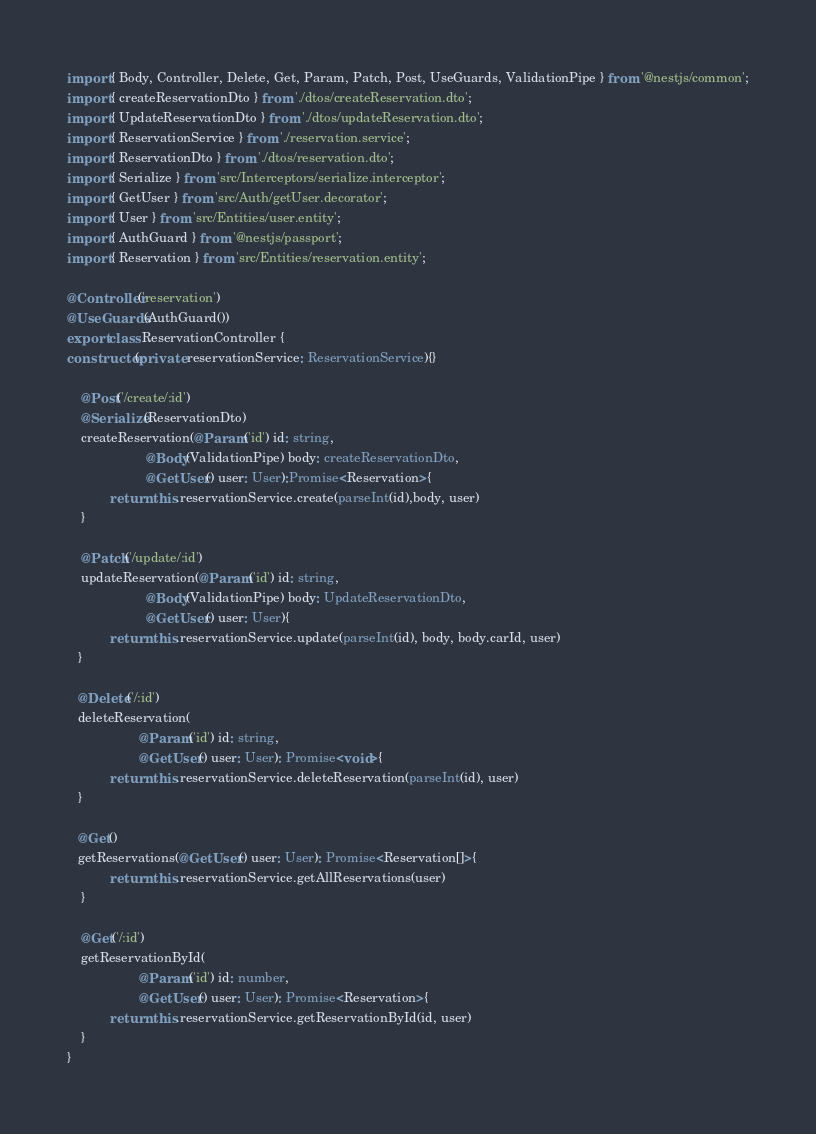Convert code to text. <code><loc_0><loc_0><loc_500><loc_500><_TypeScript_>import { Body, Controller, Delete, Get, Param, Patch, Post, UseGuards, ValidationPipe } from '@nestjs/common';
import { createReservationDto } from './dtos/createReservation.dto';
import { UpdateReservationDto } from './dtos/updateReservation.dto';
import { ReservationService } from './reservation.service';
import { ReservationDto } from './dtos/reservation.dto';
import { Serialize } from 'src/Interceptors/serialize.interceptor';
import { GetUser } from 'src/Auth/getUser.decorator';
import { User } from 'src/Entities/user.entity';
import { AuthGuard } from '@nestjs/passport';
import { Reservation } from 'src/Entities/reservation.entity';

@Controller('reservation')
@UseGuards(AuthGuard())
export class ReservationController {
constructor(private reservationService: ReservationService){}

    @Post('/create/:id')
    @Serialize(ReservationDto)
    createReservation(@Param('id') id: string, 
                      @Body(ValidationPipe) body: createReservationDto,
                      @GetUser() user: User):Promise<Reservation>{
            return this.reservationService.create(parseInt(id),body, user)
    }

    @Patch('/update/:id')
    updateReservation(@Param('id') id: string,
                      @Body(ValidationPipe) body: UpdateReservationDto,
                      @GetUser() user: User){
            return this.reservationService.update(parseInt(id), body, body.carId, user)
   }

   @Delete('/:id')
   deleteReservation(
                    @Param('id') id: string,
                    @GetUser() user: User): Promise<void>{
            return this.reservationService.deleteReservation(parseInt(id), user)
   }

   @Get()
   getReservations(@GetUser() user: User): Promise<Reservation[]>{
            return this.reservationService.getAllReservations(user)
    }

    @Get('/:id')
    getReservationById(
                    @Param('id') id: number,
                    @GetUser() user: User): Promise<Reservation>{
            return this.reservationService.getReservationById(id, user)
    }
}
</code> 